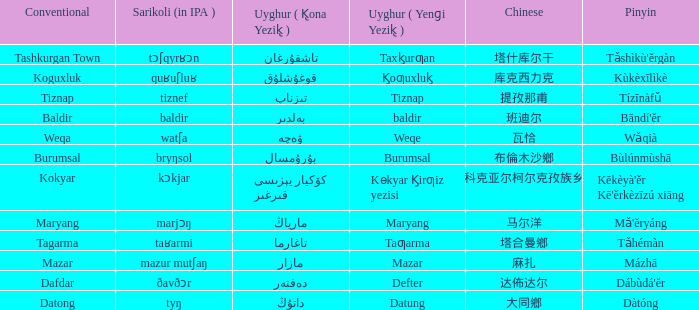Name the conventional for defter Dafdar. 